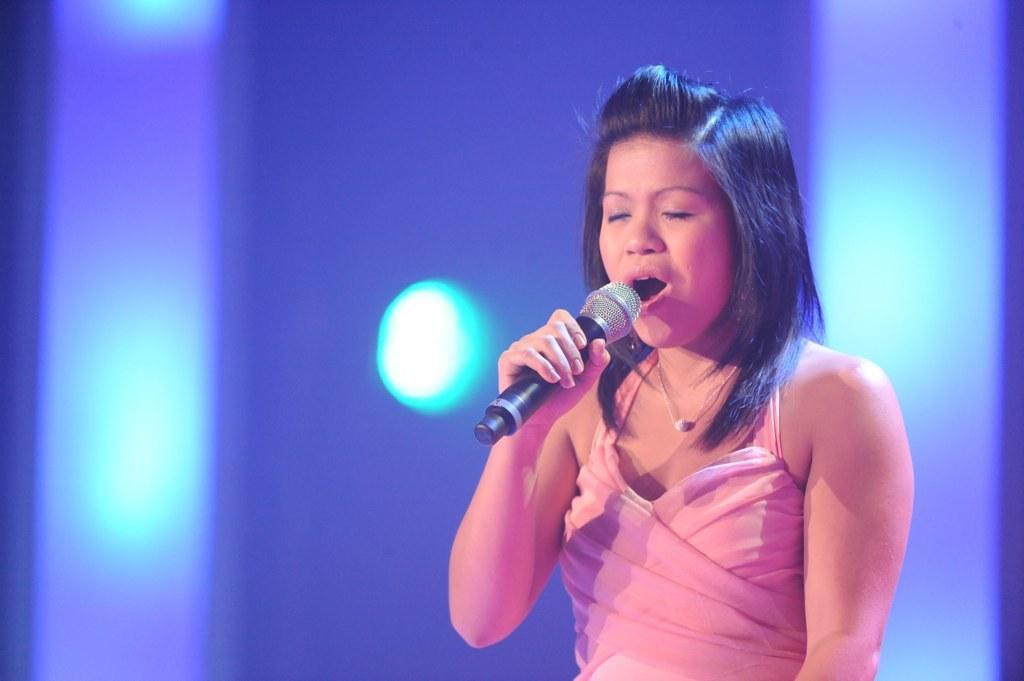Please provide a concise description of this image. This image has a woman holding a mike is singing as the mouth was widely open. 